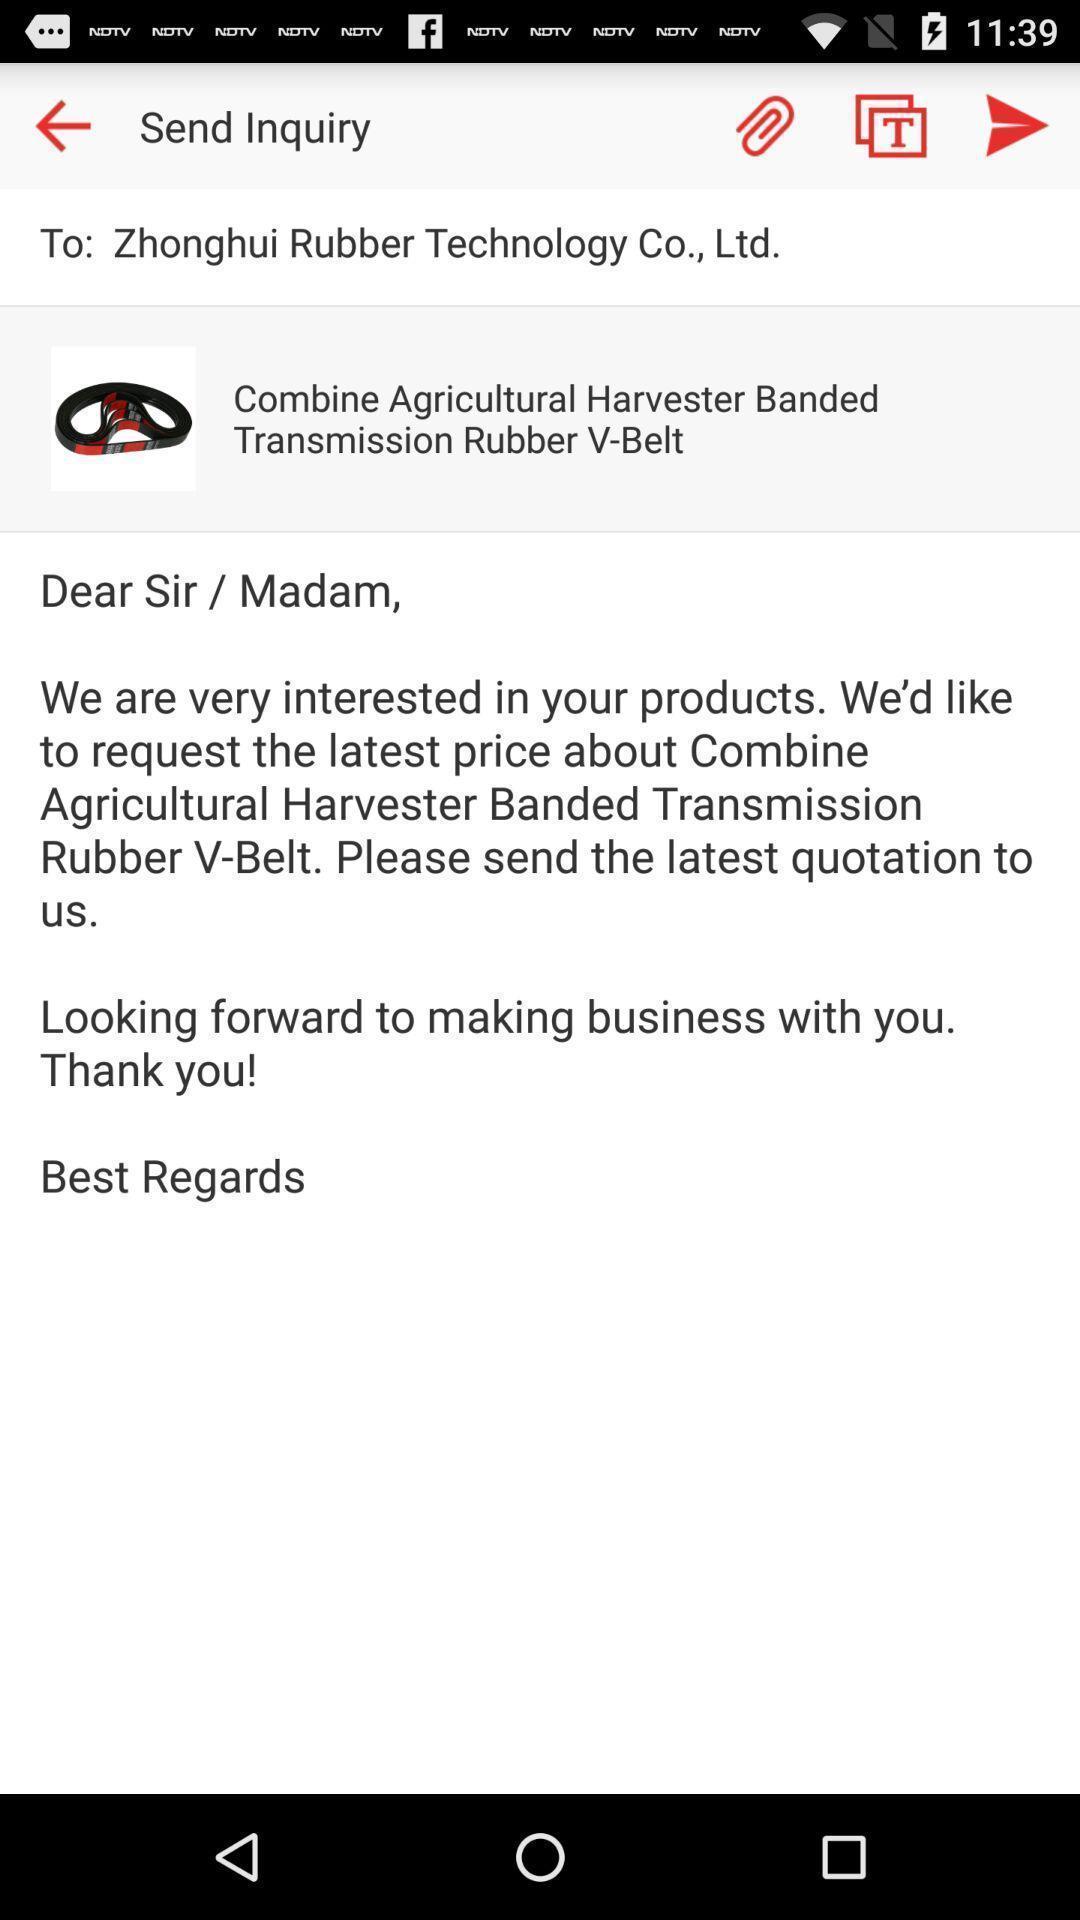Provide a description of this screenshot. Page showing message. 